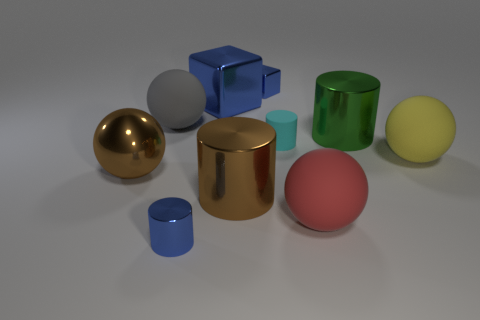Is the shape of the small thing in front of the yellow object the same as the metal thing that is on the right side of the red thing?
Your response must be concise. Yes. There is a big thing that is the same color as the small cube; what is its shape?
Offer a very short reply. Cube. What number of objects are big green cylinders that are behind the brown metallic cylinder or tiny blue metal blocks?
Your answer should be compact. 2. Do the green metal object and the cyan matte cylinder have the same size?
Keep it short and to the point. No. What color is the big cylinder that is in front of the yellow thing?
Your answer should be very brief. Brown. There is a cyan cylinder that is the same material as the yellow object; what size is it?
Your response must be concise. Small. Does the cyan object have the same size as the brown metallic thing on the left side of the gray thing?
Your response must be concise. No. What is the sphere that is behind the tiny cyan matte cylinder made of?
Your answer should be compact. Rubber. How many small cylinders are left of the big metallic cylinder on the right side of the tiny cyan rubber object?
Ensure brevity in your answer.  2. Are there any tiny blue objects of the same shape as the green metallic thing?
Offer a terse response. Yes. 